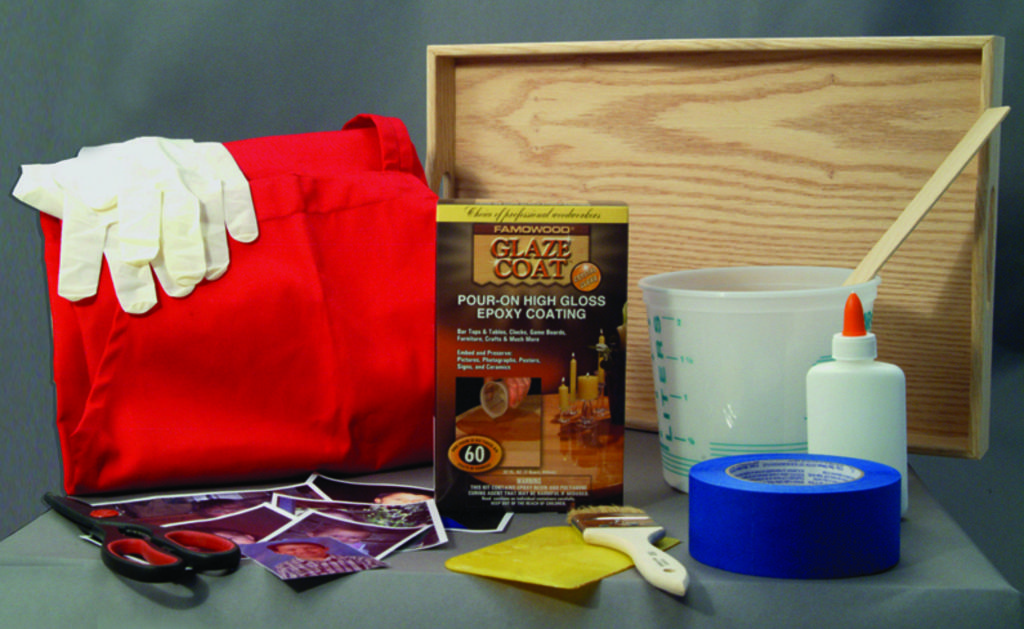What piece of furniture is visible in the image? There is a table in the image. What object related to cutting is on the table? A scissor is present on the table. What items related to photography are on the table? There are photos on the table. What tool is on the table for cleaning or applying paint? A brush is on the table. What item is on the table for attaching or securing objects? There is tape on the table. What container is on the table for holding a liquid? A bottle is on the table. What container is on the table for storing items? A box is on the table. What type of bag is on the table? A bag is on the table. What is inside the bag? The bag has gloves in it. What is on the table for holding multiple items? A tray is on the table. What type of flame can be seen on the table in the image? There is no flame present on the table in the image. What type of love is depicted in the image? There is no depiction of love in the image; it features a table with various objects on it. Is the person's grandfather in the image? There is no person or grandfather present in the image; it features a table with various objects on it. 